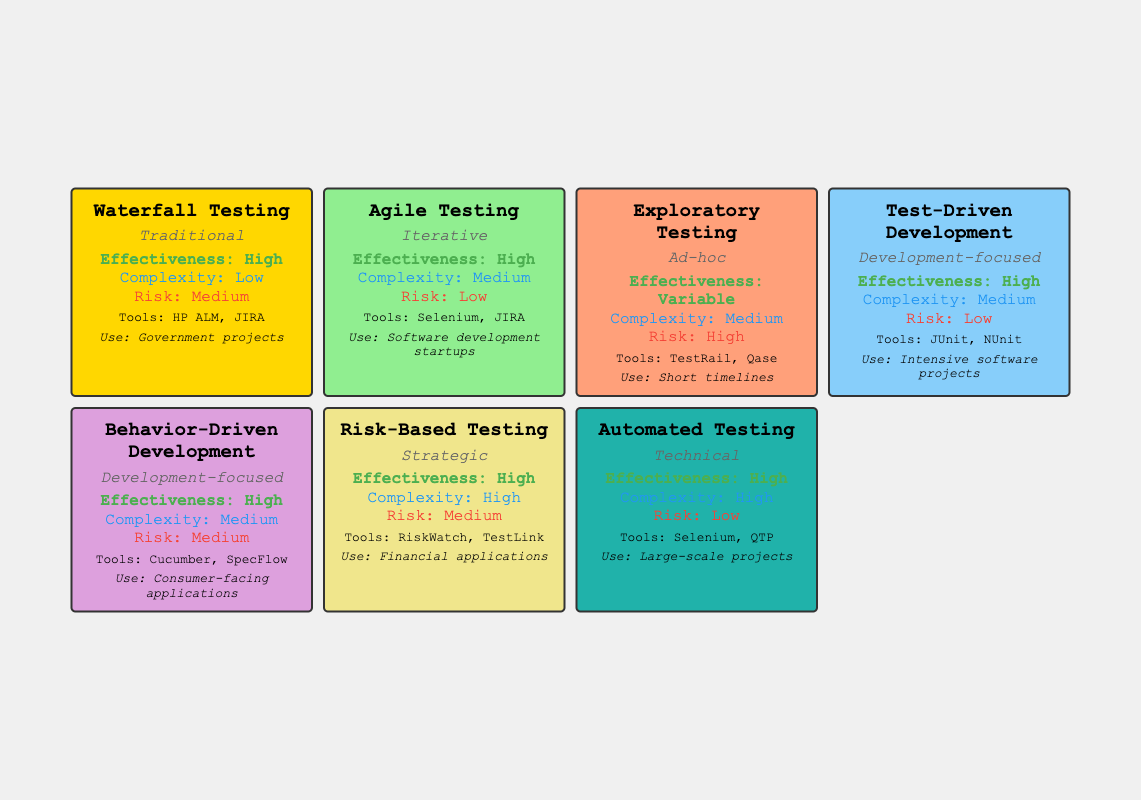What is the effectiveness of Waterfall Testing? The table shows that Waterfall Testing has the effectiveness rated as "High for well-defined projects."
Answer: High for well-defined projects What categories do Agile Testing and Automated Testing belong to? According to the table, Agile Testing is categorized as "Iterative" and Automated Testing as "Technical."
Answer: Iterative; Technical Which testing method has the highest risk level? In the table, Exploratory Testing has a risk level classified as "High," which is the highest compared to others listed.
Answer: High Is Test-Driven Development considered effective for intensive software projects? Yes, the table indicates that Test-Driven Development is rated "High" in effectiveness specifically for intensive software projects.
Answer: Yes Identify a testing method that is low risk and offers high effectiveness. The table reveals that both Agile Testing and Test-Driven Development have a low-risk level and high effectiveness rating.
Answer: Agile Testing; Test-Driven Development How many testing methods listed have a high complexity rating? From the table, Risk-Based Testing and Automated Testing are the only methods that have a "High" complexity rating, totaling to two.
Answer: 2 Would Waterfall Testing be appropriate for software development startups? The table states that Waterfall Testing is notably used for government projects, suggesting it may not be the best fit for startups.
Answer: No What is the effectiveness of Risk-Based Testing and how does it relate to its complexity? Risk-Based Testing features a "High" effectiveness rating and is categorized with "High" complexity, indicating it is effective yet complex to implement.
Answer: High effectiveness, High complexity Which testing methodologies utilize Selenium as a tool? The table indicates that both Agile Testing and Automated Testing utilize Selenium, making it a shared tool between these two methodologies.
Answer: Agile Testing; Automated Testing 